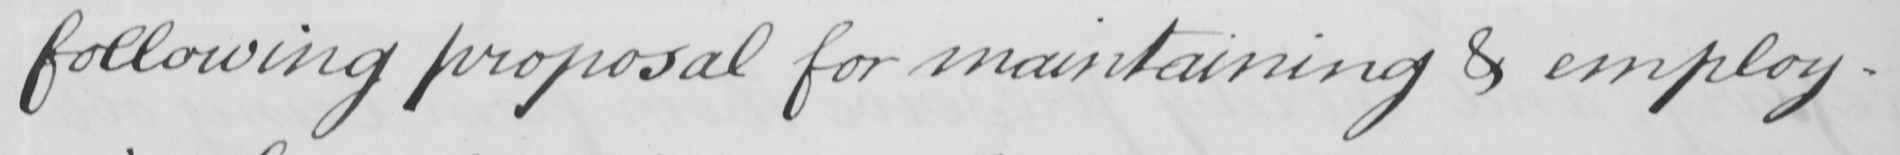Please provide the text content of this handwritten line. following proposal for maintaining & employ- 